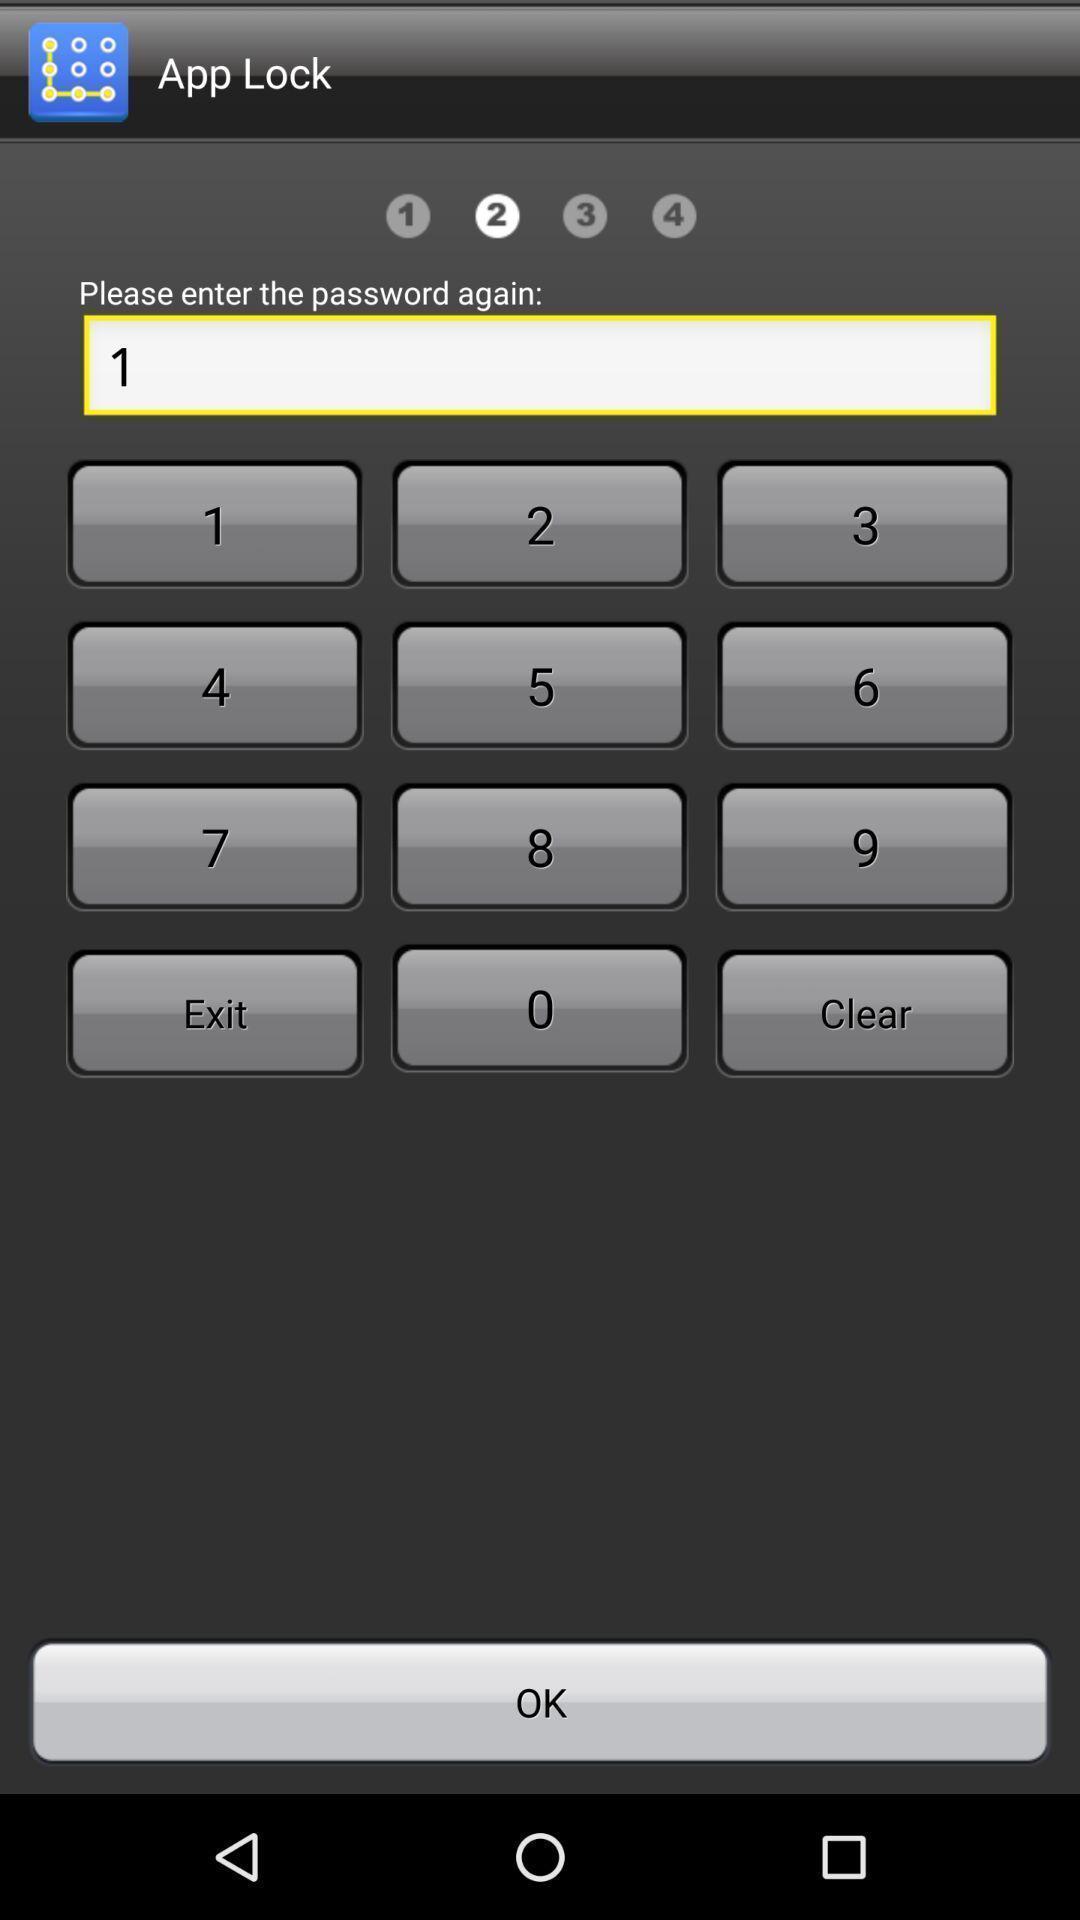Describe the visual elements of this screenshot. Page displaying to set up password for setting lock. 